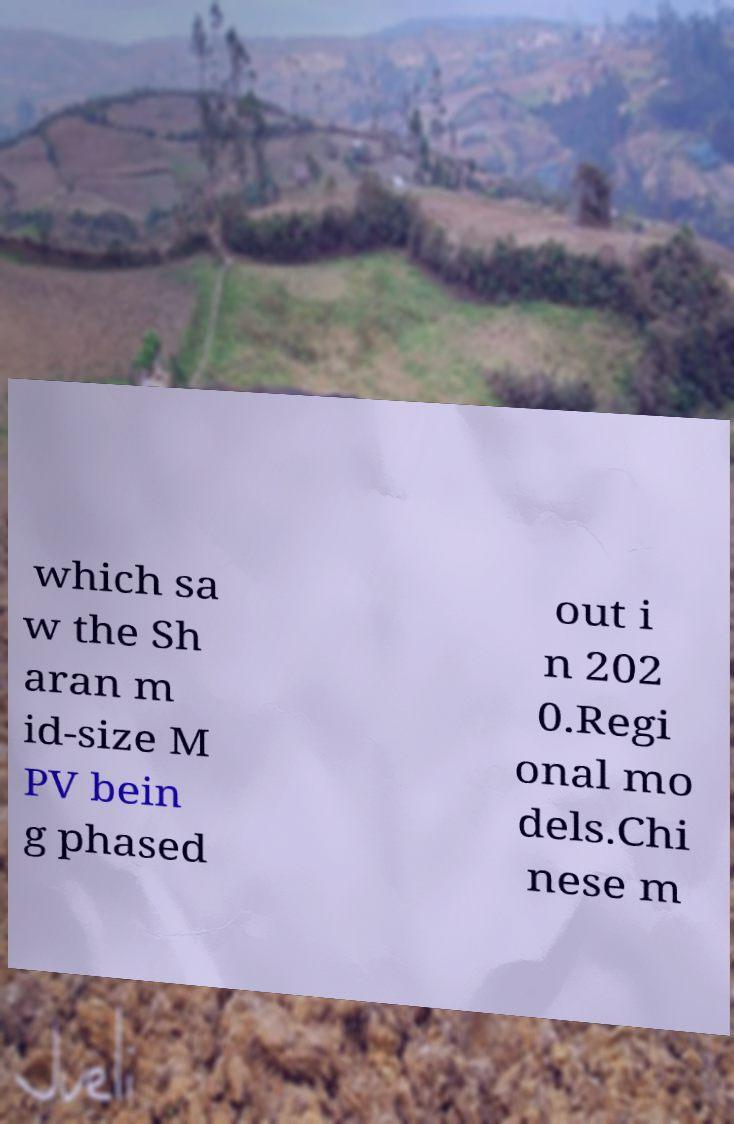What messages or text are displayed in this image? I need them in a readable, typed format. which sa w the Sh aran m id-size M PV bein g phased out i n 202 0.Regi onal mo dels.Chi nese m 